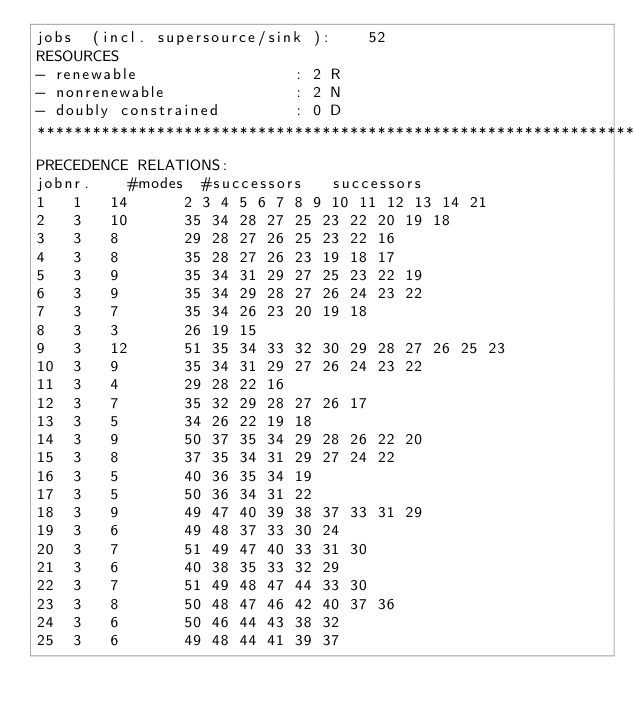Convert code to text. <code><loc_0><loc_0><loc_500><loc_500><_ObjectiveC_>jobs  (incl. supersource/sink ):	52
RESOURCES
- renewable                 : 2 R
- nonrenewable              : 2 N
- doubly constrained        : 0 D
************************************************************************
PRECEDENCE RELATIONS:
jobnr.    #modes  #successors   successors
1	1	14		2 3 4 5 6 7 8 9 10 11 12 13 14 21 
2	3	10		35 34 28 27 25 23 22 20 19 18 
3	3	8		29 28 27 26 25 23 22 16 
4	3	8		35 28 27 26 23 19 18 17 
5	3	9		35 34 31 29 27 25 23 22 19 
6	3	9		35 34 29 28 27 26 24 23 22 
7	3	7		35 34 26 23 20 19 18 
8	3	3		26 19 15 
9	3	12		51 35 34 33 32 30 29 28 27 26 25 23 
10	3	9		35 34 31 29 27 26 24 23 22 
11	3	4		29 28 22 16 
12	3	7		35 32 29 28 27 26 17 
13	3	5		34 26 22 19 18 
14	3	9		50 37 35 34 29 28 26 22 20 
15	3	8		37 35 34 31 29 27 24 22 
16	3	5		40 36 35 34 19 
17	3	5		50 36 34 31 22 
18	3	9		49 47 40 39 38 37 33 31 29 
19	3	6		49 48 37 33 30 24 
20	3	7		51 49 47 40 33 31 30 
21	3	6		40 38 35 33 32 29 
22	3	7		51 49 48 47 44 33 30 
23	3	8		50 48 47 46 42 40 37 36 
24	3	6		50 46 44 43 38 32 
25	3	6		49 48 44 41 39 37 </code> 